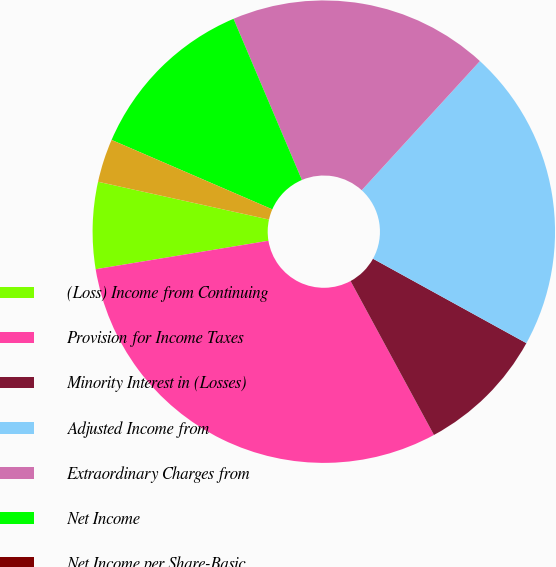Convert chart. <chart><loc_0><loc_0><loc_500><loc_500><pie_chart><fcel>(Loss) Income from Continuing<fcel>Provision for Income Taxes<fcel>Minority Interest in (Losses)<fcel>Adjusted Income from<fcel>Extraordinary Charges from<fcel>Net Income<fcel>Net Income per Share-Basic<fcel>Net Income per Share-Diluted<nl><fcel>6.06%<fcel>30.3%<fcel>9.09%<fcel>21.21%<fcel>18.18%<fcel>12.12%<fcel>0.0%<fcel>3.03%<nl></chart> 